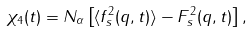Convert formula to latex. <formula><loc_0><loc_0><loc_500><loc_500>\chi _ { 4 } ( t ) = N _ { \alpha } \left [ \langle f _ { s } ^ { 2 } ( { q } , t ) \rangle - F _ { s } ^ { 2 } ( { q } , t ) \right ] ,</formula> 